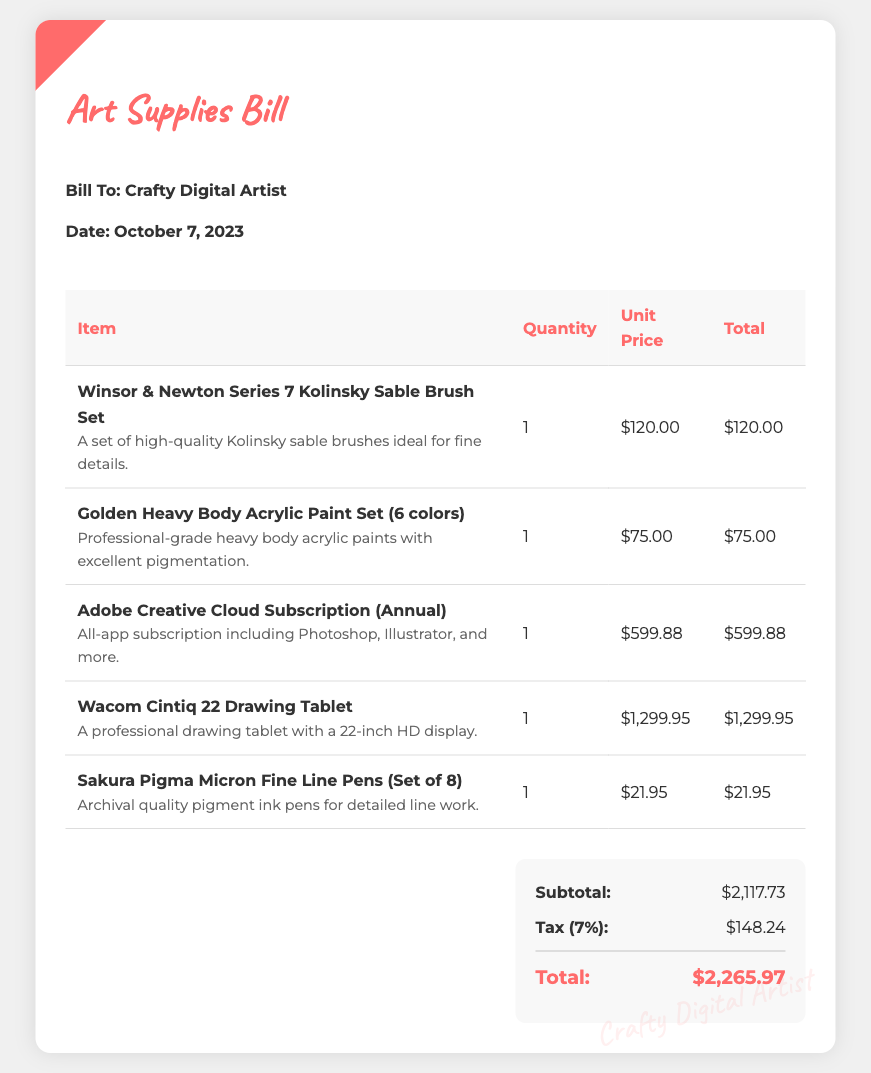What is the date of the bill? The date of the bill is listed in the document under the "Date" section.
Answer: October 7, 2023 What is the total amount due? The total amount due is specified at the bottom of the bill in the total section.
Answer: $2,265.97 How many items are listed in the bill? The bill shows a table with the items, and we can count them to determine the total.
Answer: 5 What is the unit price of the Wacom Cintiq 22 Drawing Tablet? The unit price for this item is indicated in the respective row of the table.
Answer: $1,299.95 What is the tax rate applied in the bill? The tax rate is mentioned in the tax row of the total section of the bill.
Answer: 7% What item has the highest cost? We can compare the total costs of each item to identify the one with the highest price.
Answer: Wacom Cintiq 22 Drawing Tablet What is the subtotal before tax? The subtotal is listed right above the tax amount in the total section.
Answer: $2,117.73 What type of brush is included in the bill? The item description specifies the type of the brush in the document under the respective item.
Answer: Kolinsky Sable What is the quantity of Golden Heavy Body Acrylic Paint Set purchased? The document lists the quantity for each item in the respective column of the table.
Answer: 1 